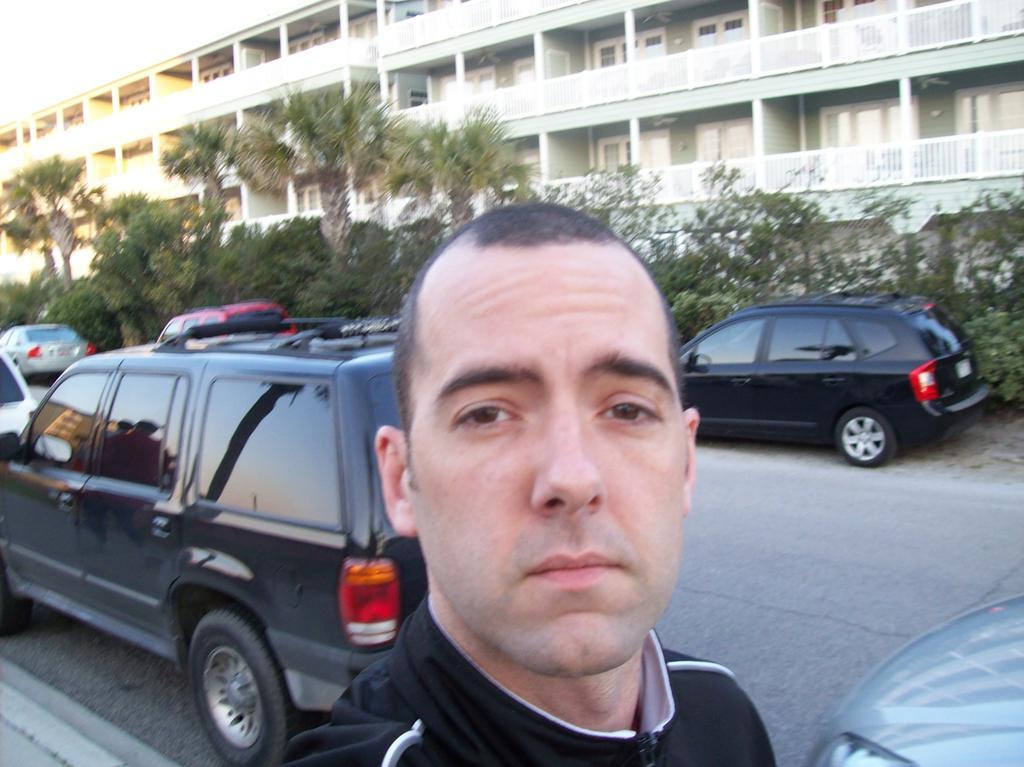Describe this image in one or two sentences. In this picture there is a man standing in the front and looking at the camera. Behind there is a car and some trees. In the background there is a building with balcony grills. 